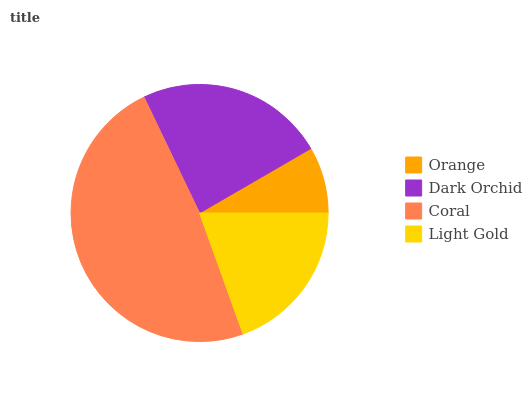Is Orange the minimum?
Answer yes or no. Yes. Is Coral the maximum?
Answer yes or no. Yes. Is Dark Orchid the minimum?
Answer yes or no. No. Is Dark Orchid the maximum?
Answer yes or no. No. Is Dark Orchid greater than Orange?
Answer yes or no. Yes. Is Orange less than Dark Orchid?
Answer yes or no. Yes. Is Orange greater than Dark Orchid?
Answer yes or no. No. Is Dark Orchid less than Orange?
Answer yes or no. No. Is Dark Orchid the high median?
Answer yes or no. Yes. Is Light Gold the low median?
Answer yes or no. Yes. Is Coral the high median?
Answer yes or no. No. Is Orange the low median?
Answer yes or no. No. 